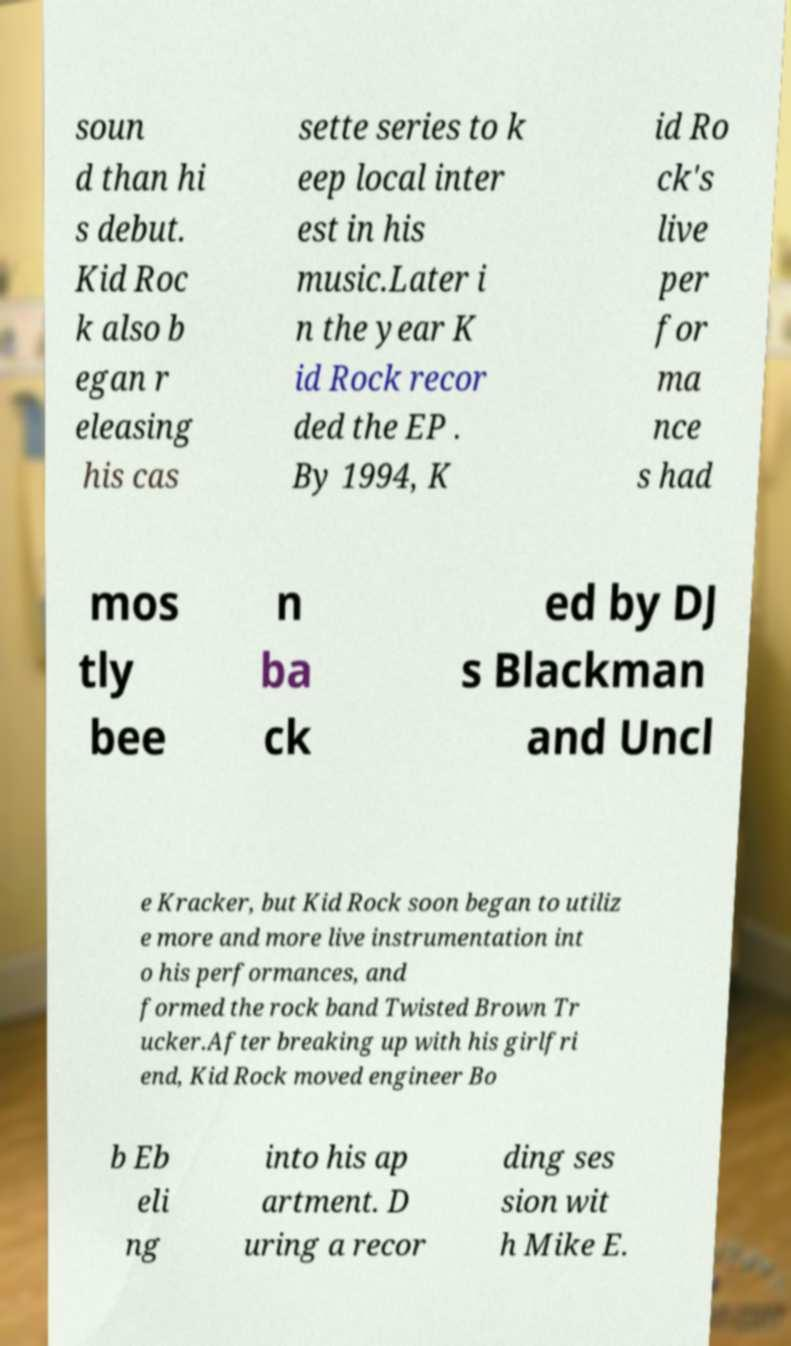Could you extract and type out the text from this image? soun d than hi s debut. Kid Roc k also b egan r eleasing his cas sette series to k eep local inter est in his music.Later i n the year K id Rock recor ded the EP . By 1994, K id Ro ck's live per for ma nce s had mos tly bee n ba ck ed by DJ s Blackman and Uncl e Kracker, but Kid Rock soon began to utiliz e more and more live instrumentation int o his performances, and formed the rock band Twisted Brown Tr ucker.After breaking up with his girlfri end, Kid Rock moved engineer Bo b Eb eli ng into his ap artment. D uring a recor ding ses sion wit h Mike E. 